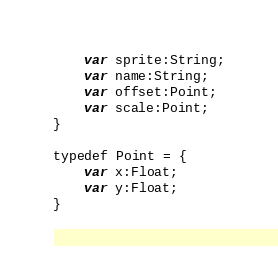<code> <loc_0><loc_0><loc_500><loc_500><_Haxe_>    var sprite:String;
    var name:String;
    var offset:Point;
    var scale:Point;
}

typedef Point = {
    var x:Float;
    var y:Float;
}</code> 